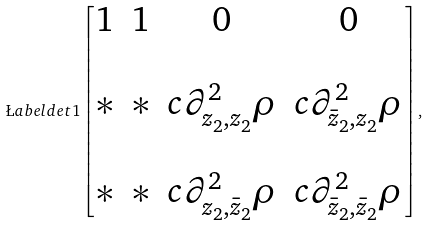<formula> <loc_0><loc_0><loc_500><loc_500>\L a b e l { d e t 1 } \left [ \begin{matrix} 1 & 1 & 0 & 0 \\ & & & \\ * & * & c \partial ^ { 2 } _ { z _ { 2 } , z _ { 2 } } \rho & c \partial ^ { 2 } _ { \bar { z } _ { 2 } , z _ { 2 } } \rho \\ & & & \\ * & * & c \partial ^ { 2 } _ { z _ { 2 } , \bar { z } _ { 2 } } \rho & c \partial ^ { 2 } _ { \bar { z } _ { 2 } , \bar { z } _ { 2 } } \rho \end{matrix} \right ] ,</formula> 